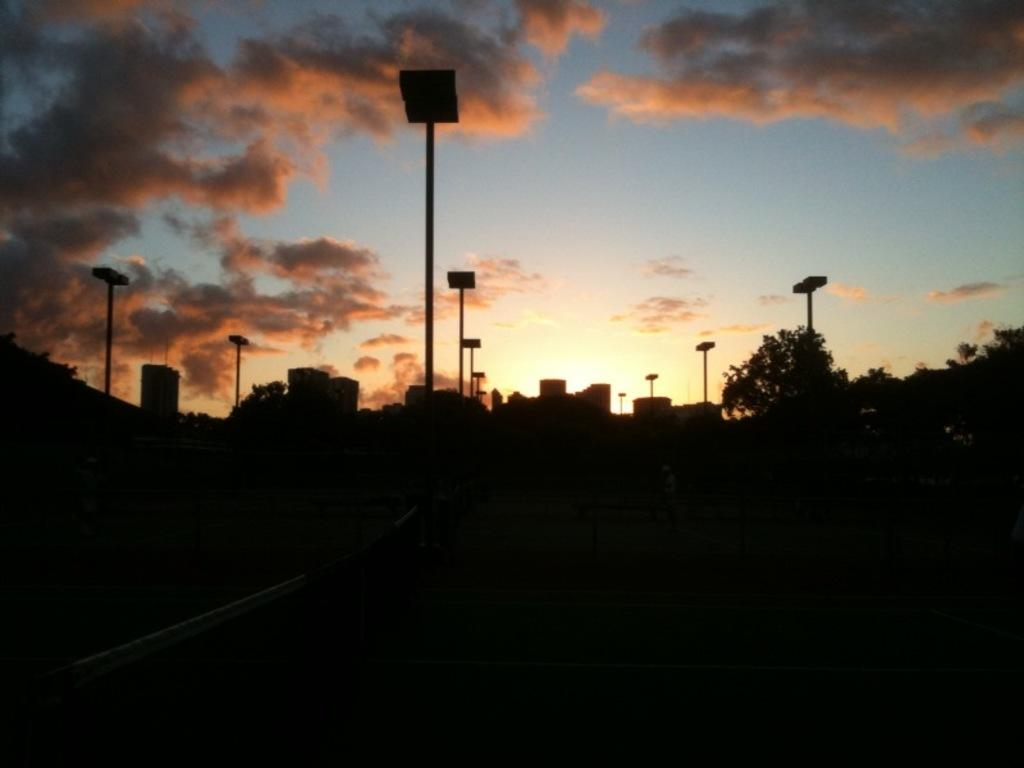What structures can be seen in the image? There are poles in the image. What can be seen in the distance behind the poles? There are buildings and trees in the background of the image. What is visible above the buildings and trees? The sky is visible in the image. What can be observed in the sky? Clouds are present in the sky. Where are the ants located in the image? There are no ants present in the image. What type of furniture can be seen in the image? There is no furniture present in the image. 